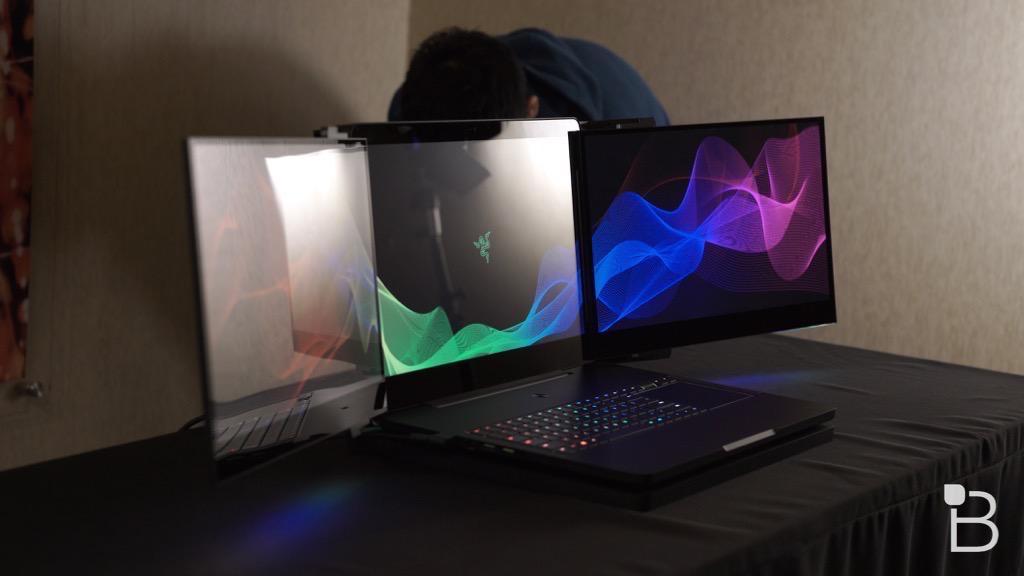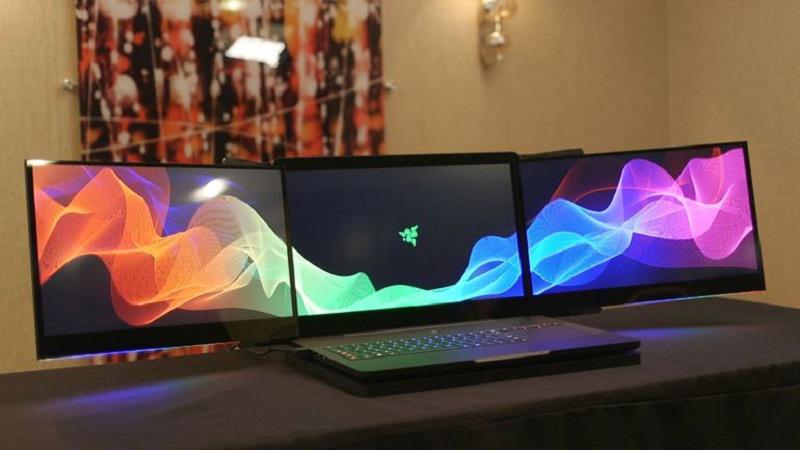The first image is the image on the left, the second image is the image on the right. Examine the images to the left and right. Is the description "there is a latop on a desk with 2 extra monitors mounted to the original screen" accurate? Answer yes or no. Yes. 